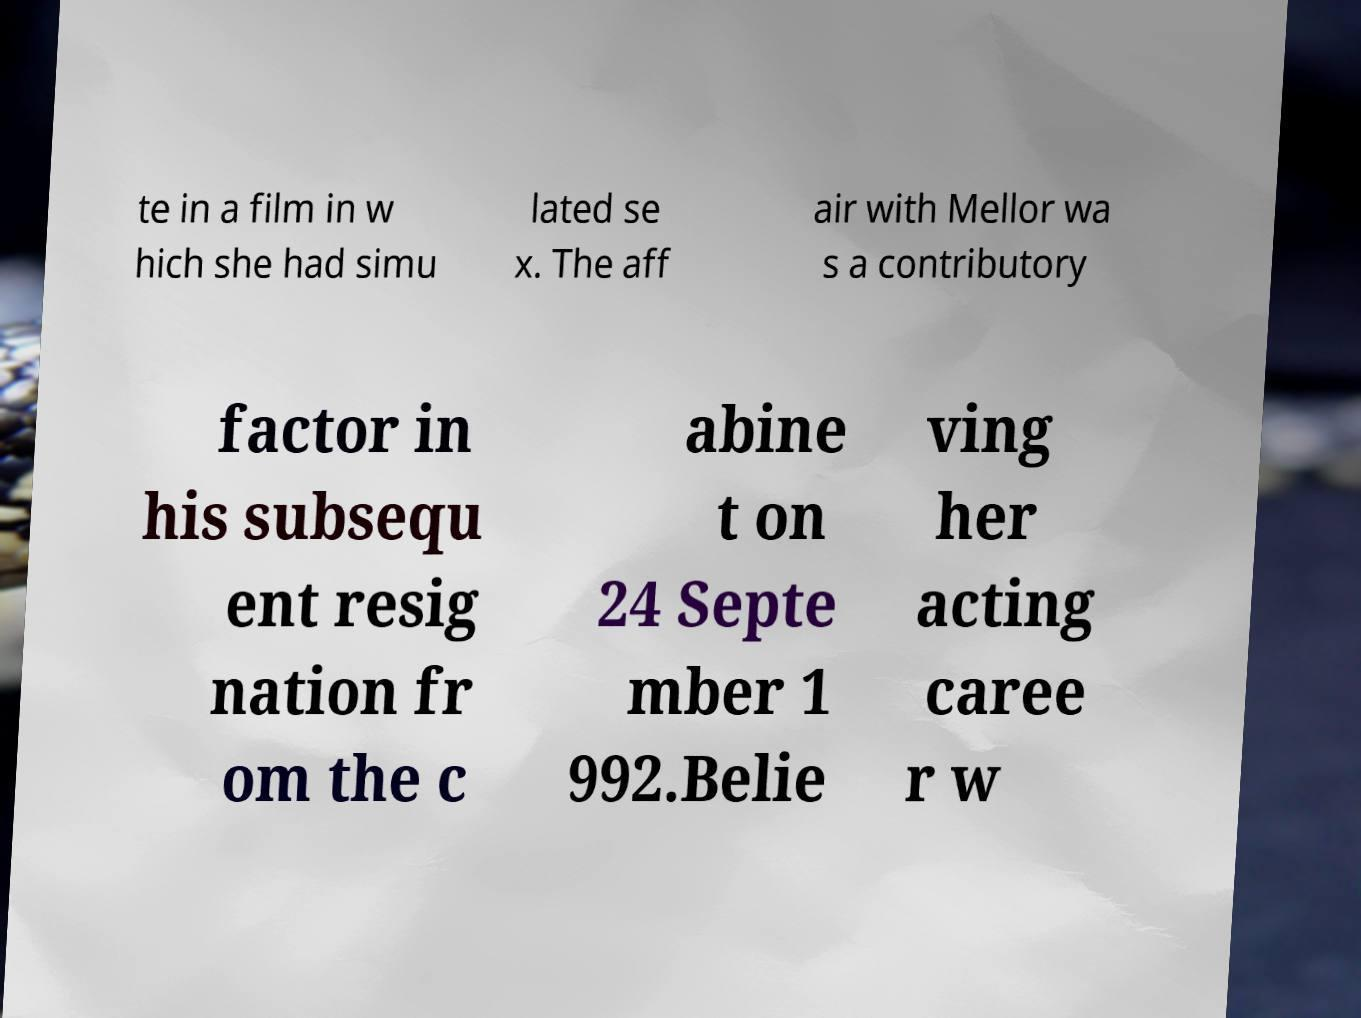Please read and relay the text visible in this image. What does it say? te in a film in w hich she had simu lated se x. The aff air with Mellor wa s a contributory factor in his subsequ ent resig nation fr om the c abine t on 24 Septe mber 1 992.Belie ving her acting caree r w 